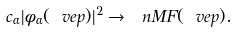<formula> <loc_0><loc_0><loc_500><loc_500>c _ { \alpha } | \phi _ { \alpha } ( \ v e p ) | ^ { 2 } \rightarrow \ n M F ( \ v e p ) .</formula> 